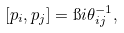Convert formula to latex. <formula><loc_0><loc_0><loc_500><loc_500>[ p _ { i } , p _ { j } ] = \i i \theta _ { i j } ^ { - 1 } ,</formula> 